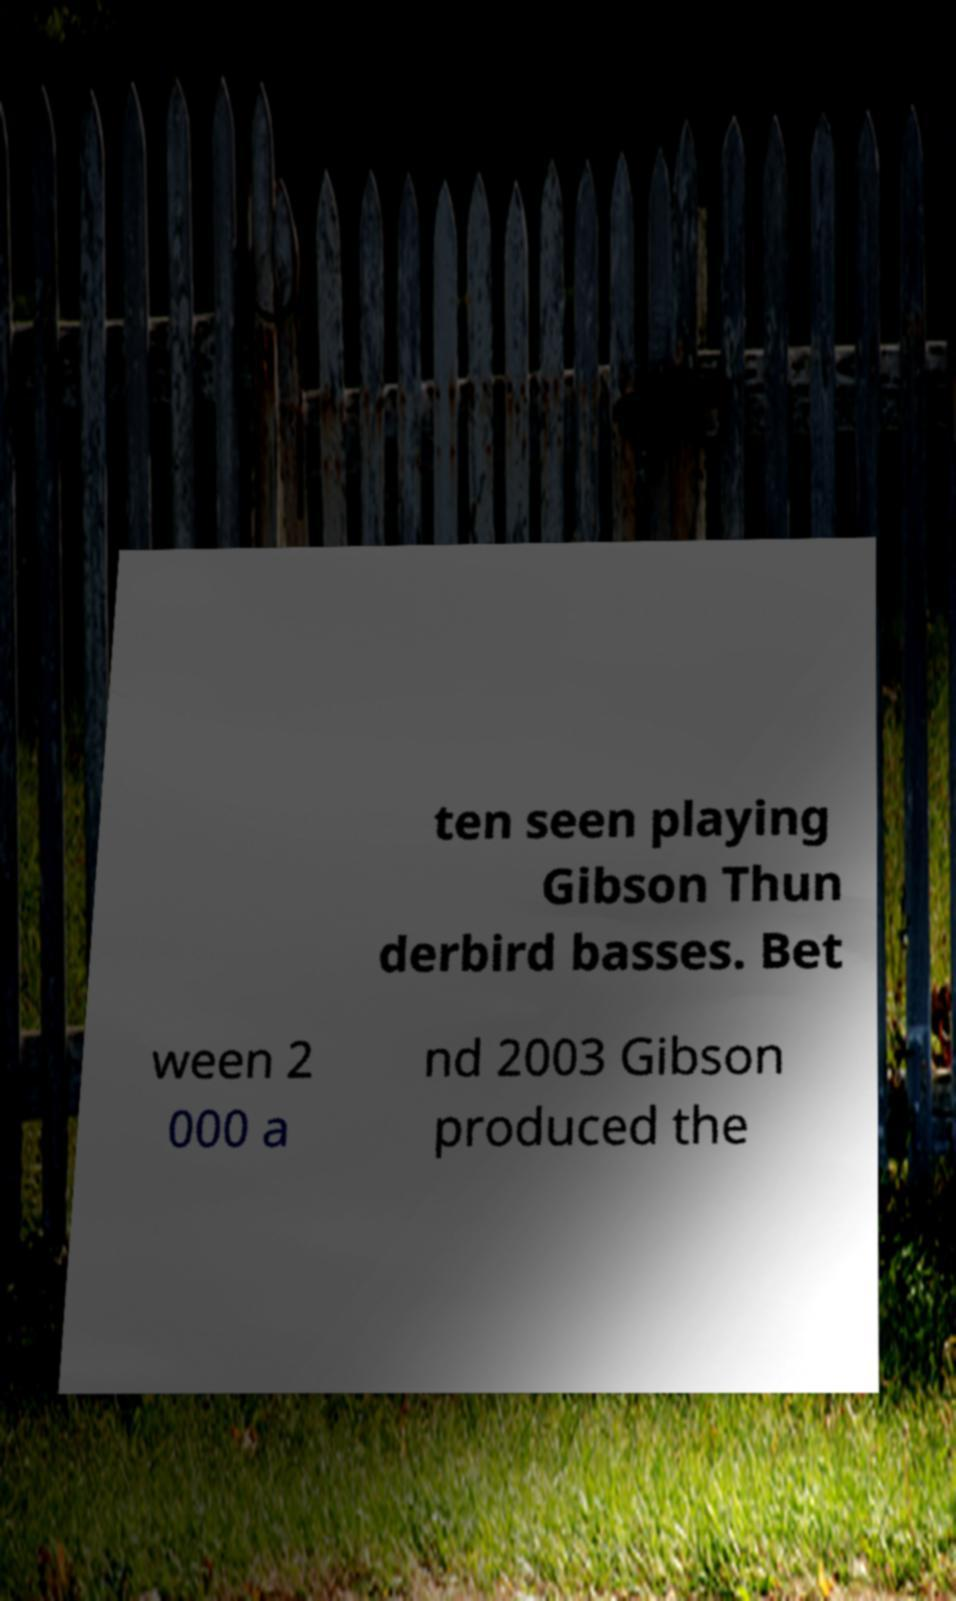There's text embedded in this image that I need extracted. Can you transcribe it verbatim? ten seen playing Gibson Thun derbird basses. Bet ween 2 000 a nd 2003 Gibson produced the 